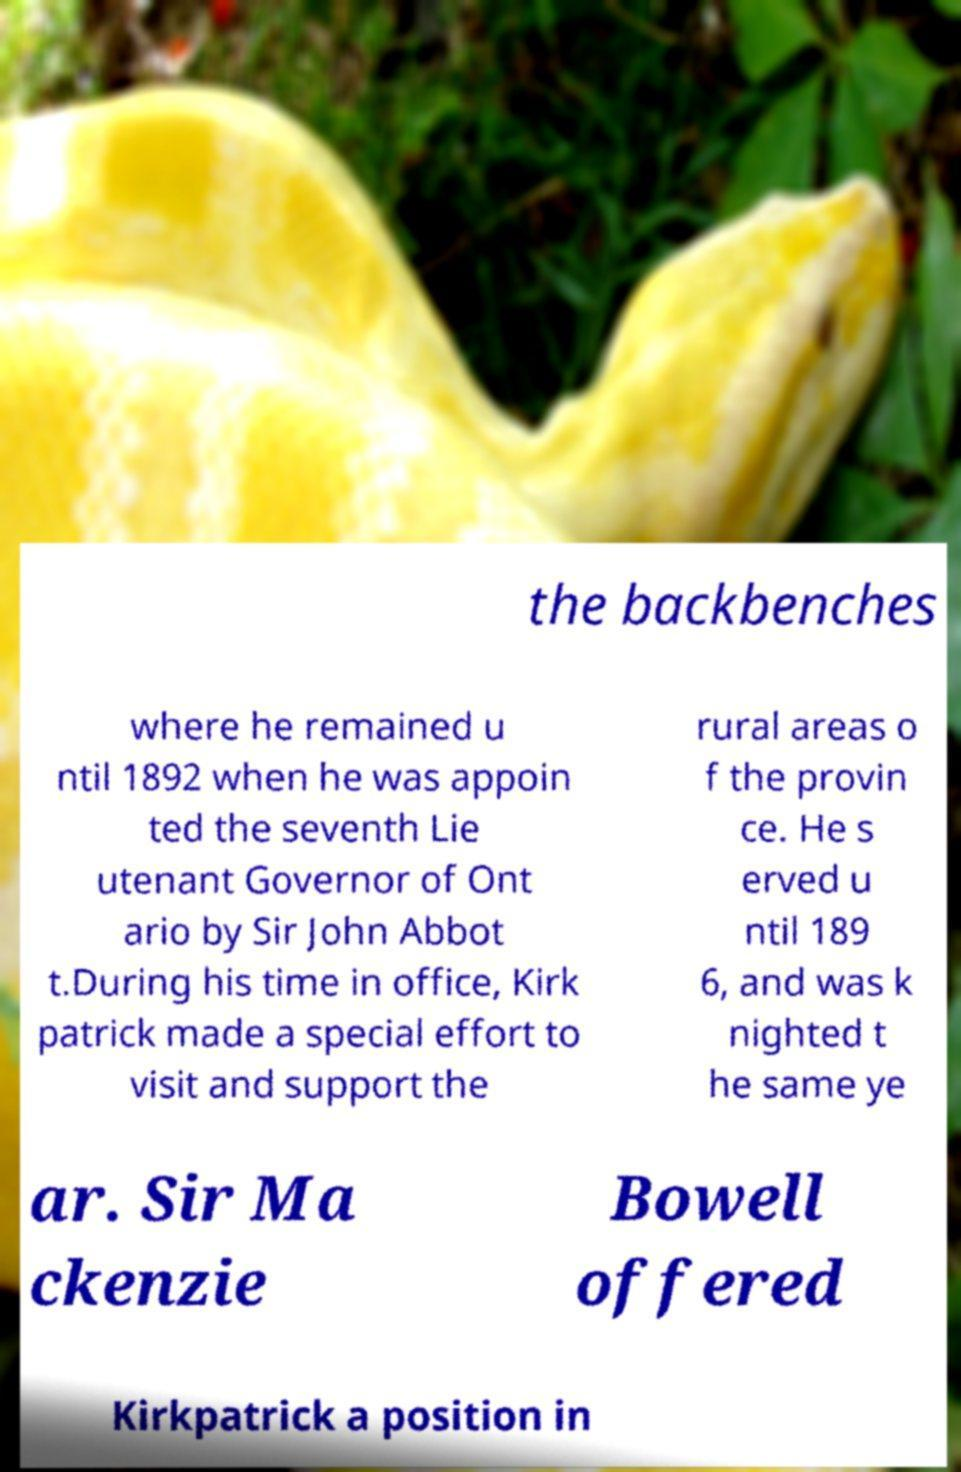Could you extract and type out the text from this image? the backbenches where he remained u ntil 1892 when he was appoin ted the seventh Lie utenant Governor of Ont ario by Sir John Abbot t.During his time in office, Kirk patrick made a special effort to visit and support the rural areas o f the provin ce. He s erved u ntil 189 6, and was k nighted t he same ye ar. Sir Ma ckenzie Bowell offered Kirkpatrick a position in 